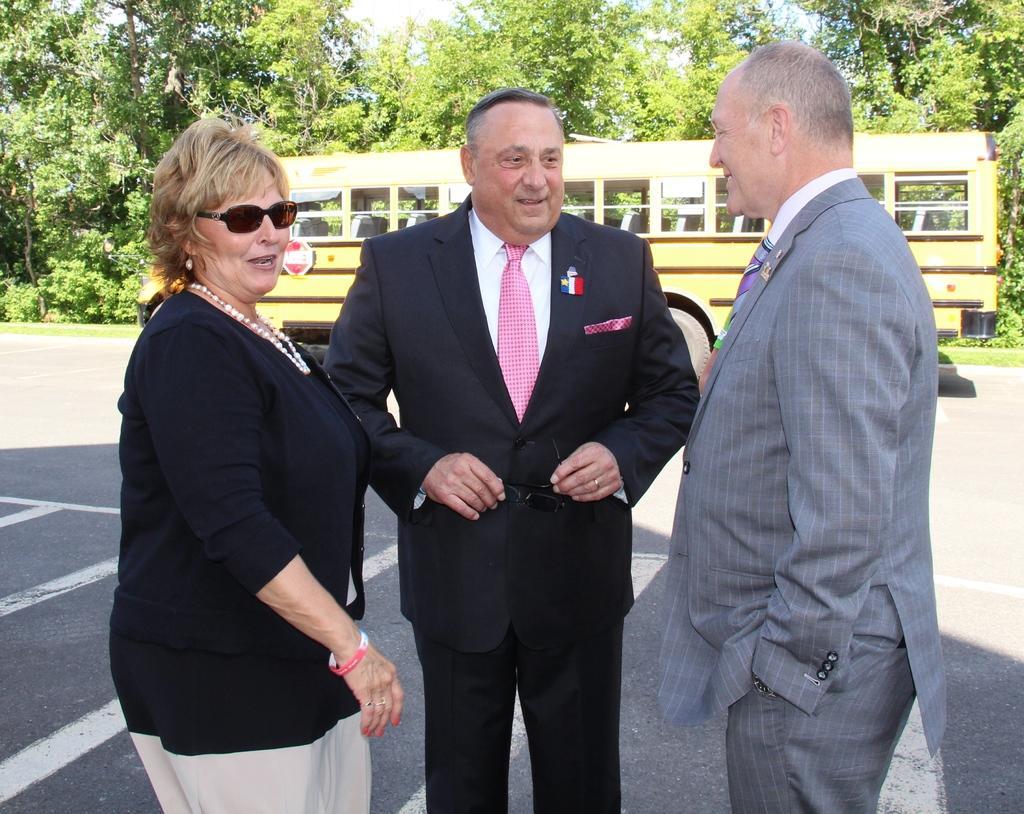How would you summarize this image in a sentence or two? In this picture we can see three people standing, smiling and a man holding goggles. In the background we can see a bus on the road, trees and the sky. 